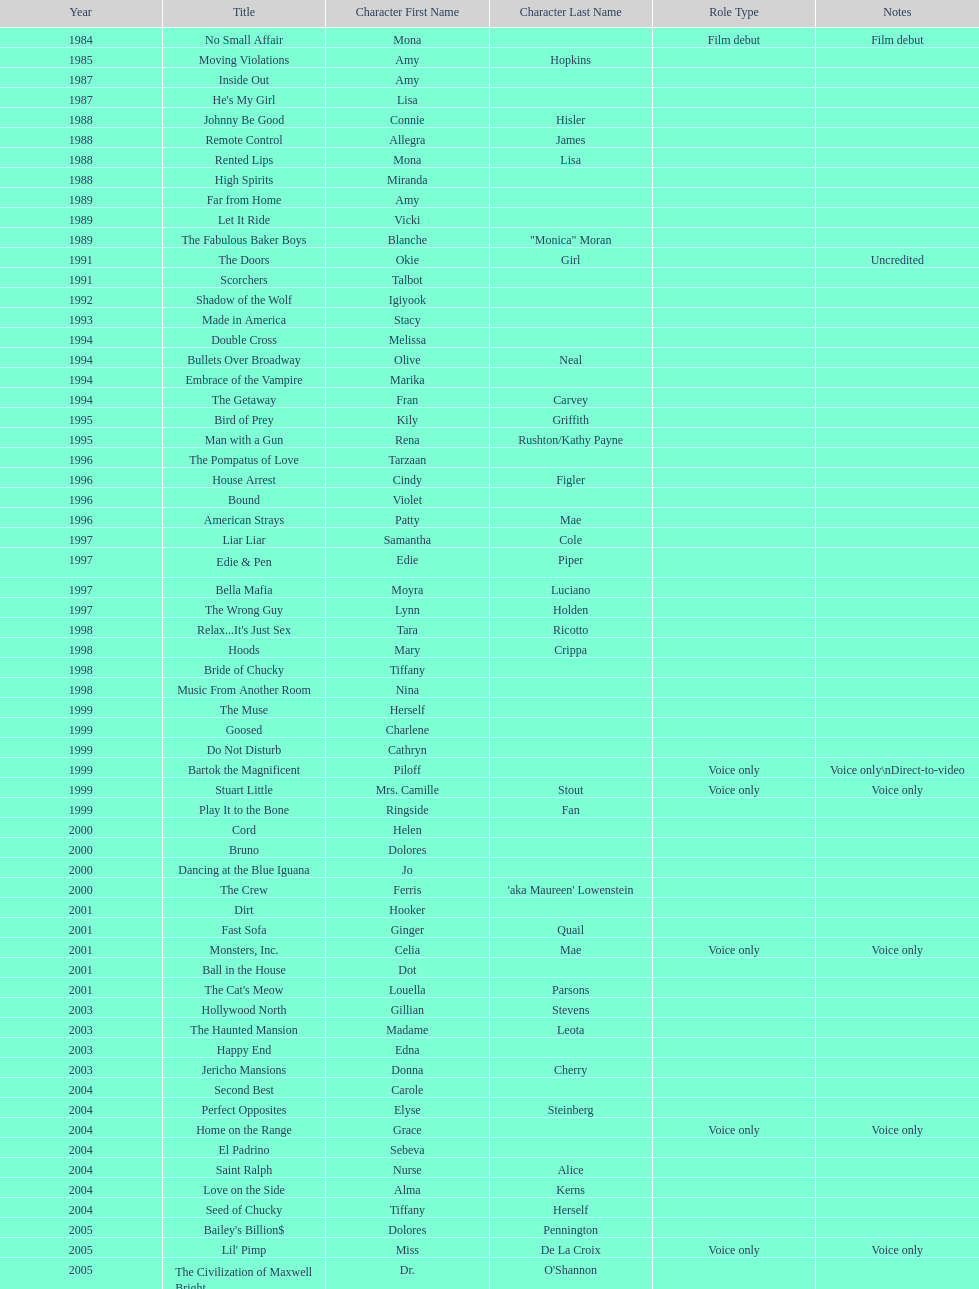Which movie was also a film debut? No Small Affair. 